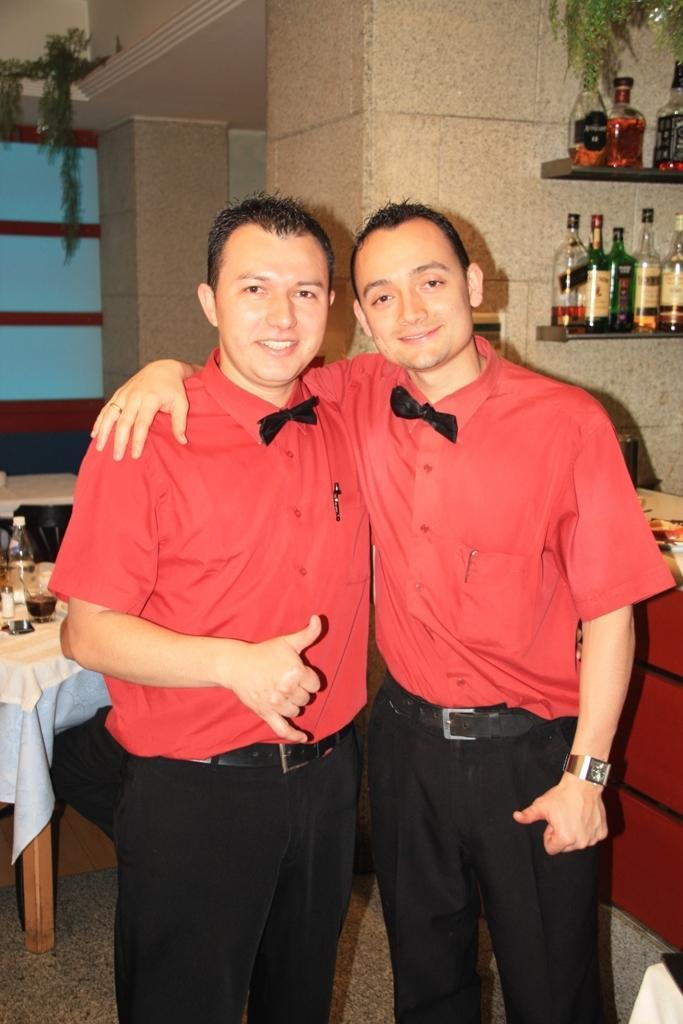In one or two sentences, can you explain what this image depicts? This image is taken indoors. At the bottom of the image there is a floor. In the middle of the image two men are standing on the floor and they have worn same shirts and pants. On the left side of the image there is a table with a tablecloth and a few things on it. In the background there are a few walls with a window and a pillar. On the right side of the image there are two shelves with a few bottles on them. 